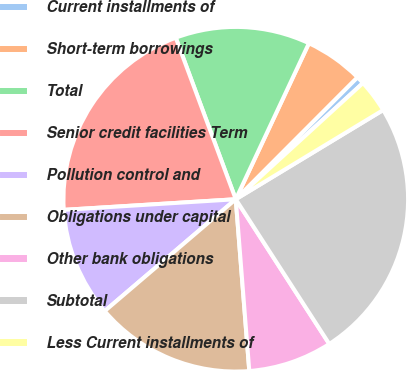Convert chart. <chart><loc_0><loc_0><loc_500><loc_500><pie_chart><fcel>Current installments of<fcel>Short-term borrowings<fcel>Total<fcel>Senior credit facilities Term<fcel>Pollution control and<fcel>Obligations under capital<fcel>Other bank obligations<fcel>Subtotal<fcel>Less Current installments of<nl><fcel>0.74%<fcel>5.5%<fcel>12.64%<fcel>20.32%<fcel>10.26%<fcel>15.01%<fcel>7.88%<fcel>24.53%<fcel>3.12%<nl></chart> 